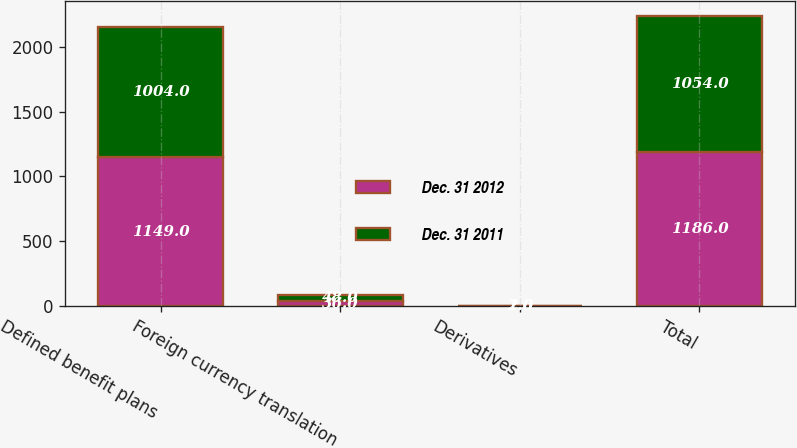Convert chart. <chart><loc_0><loc_0><loc_500><loc_500><stacked_bar_chart><ecel><fcel>Defined benefit plans<fcel>Foreign currency translation<fcel>Derivatives<fcel>Total<nl><fcel>Dec. 31 2012<fcel>1149<fcel>36<fcel>1<fcel>1186<nl><fcel>Dec. 31 2011<fcel>1004<fcel>48<fcel>2<fcel>1054<nl></chart> 